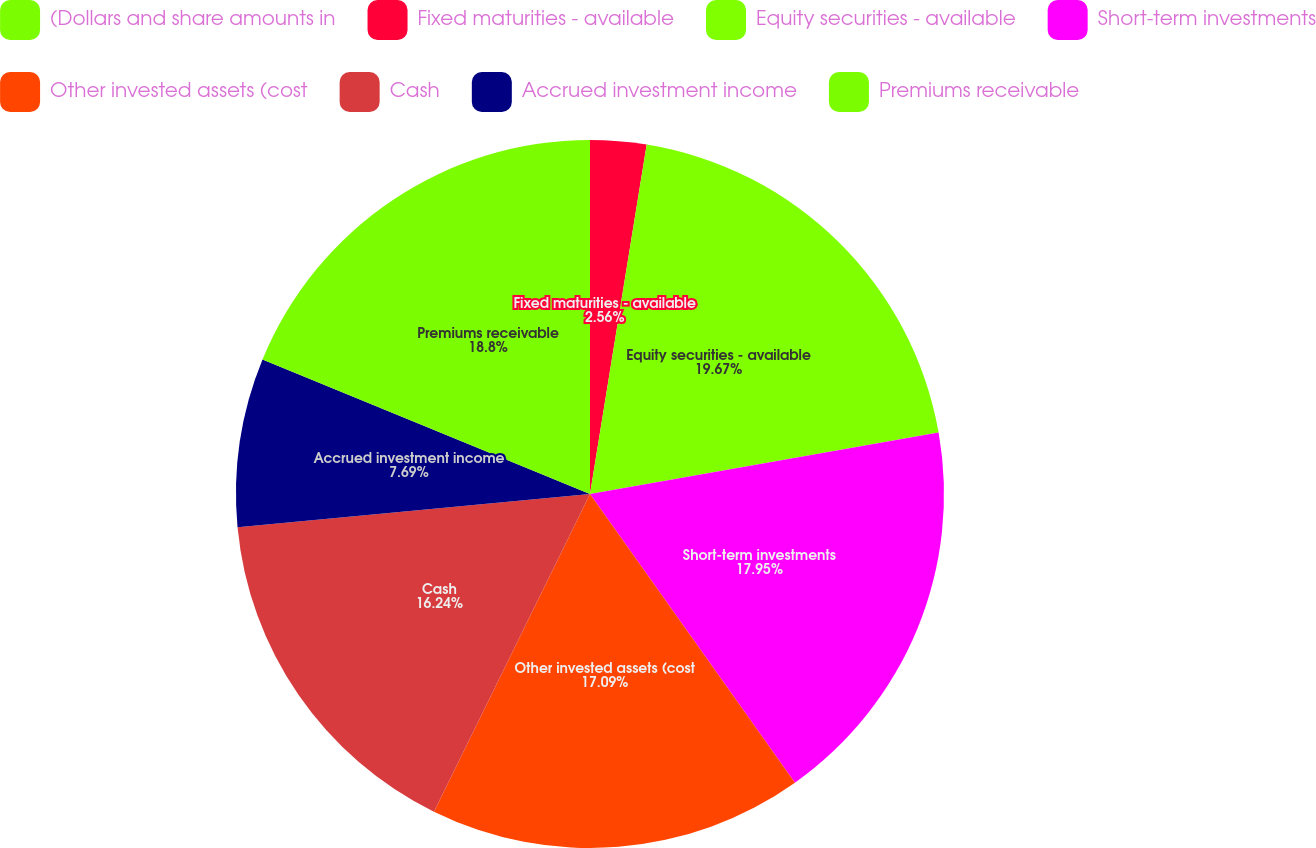<chart> <loc_0><loc_0><loc_500><loc_500><pie_chart><fcel>(Dollars and share amounts in<fcel>Fixed maturities - available<fcel>Equity securities - available<fcel>Short-term investments<fcel>Other invested assets (cost<fcel>Cash<fcel>Accrued investment income<fcel>Premiums receivable<nl><fcel>0.0%<fcel>2.56%<fcel>19.66%<fcel>17.95%<fcel>17.09%<fcel>16.24%<fcel>7.69%<fcel>18.8%<nl></chart> 